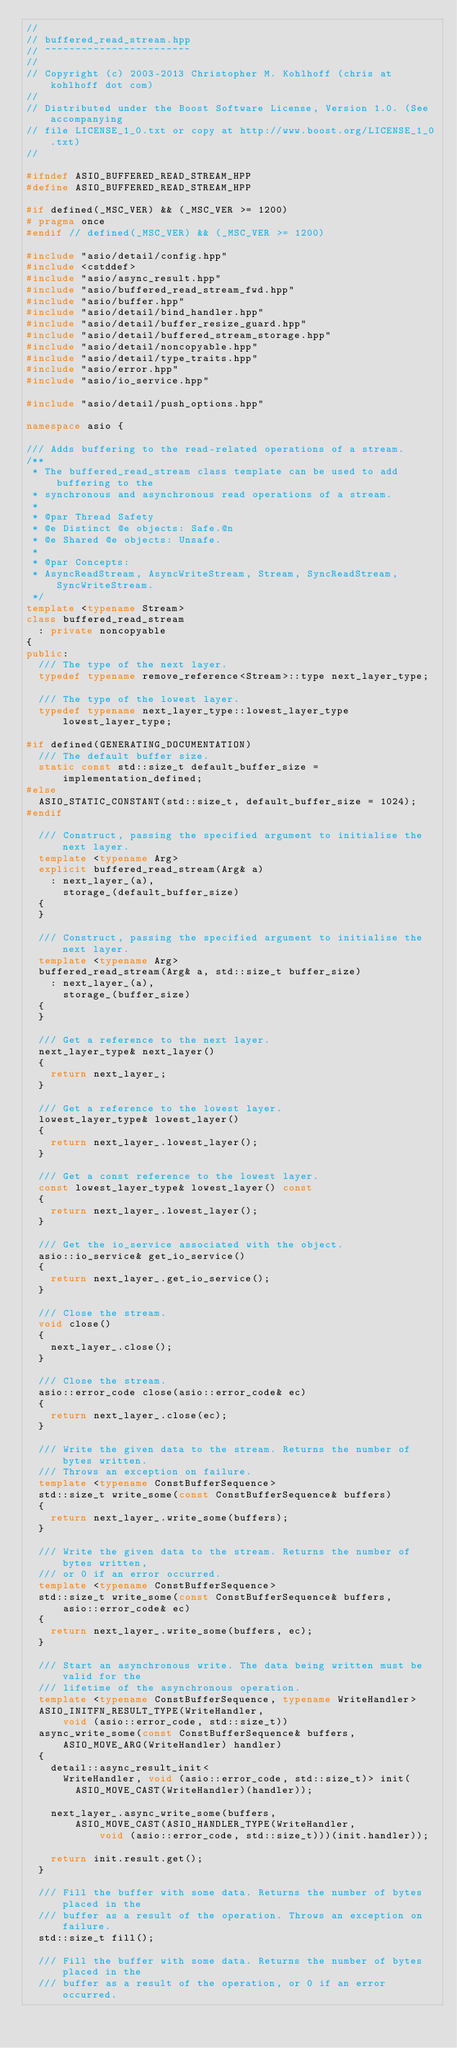<code> <loc_0><loc_0><loc_500><loc_500><_C++_>//
// buffered_read_stream.hpp
// ~~~~~~~~~~~~~~~~~~~~~~~~
//
// Copyright (c) 2003-2013 Christopher M. Kohlhoff (chris at kohlhoff dot com)
//
// Distributed under the Boost Software License, Version 1.0. (See accompanying
// file LICENSE_1_0.txt or copy at http://www.boost.org/LICENSE_1_0.txt)
//

#ifndef ASIO_BUFFERED_READ_STREAM_HPP
#define ASIO_BUFFERED_READ_STREAM_HPP

#if defined(_MSC_VER) && (_MSC_VER >= 1200)
# pragma once
#endif // defined(_MSC_VER) && (_MSC_VER >= 1200)

#include "asio/detail/config.hpp"
#include <cstddef>
#include "asio/async_result.hpp"
#include "asio/buffered_read_stream_fwd.hpp"
#include "asio/buffer.hpp"
#include "asio/detail/bind_handler.hpp"
#include "asio/detail/buffer_resize_guard.hpp"
#include "asio/detail/buffered_stream_storage.hpp"
#include "asio/detail/noncopyable.hpp"
#include "asio/detail/type_traits.hpp"
#include "asio/error.hpp"
#include "asio/io_service.hpp"

#include "asio/detail/push_options.hpp"

namespace asio {

/// Adds buffering to the read-related operations of a stream.
/**
 * The buffered_read_stream class template can be used to add buffering to the
 * synchronous and asynchronous read operations of a stream.
 *
 * @par Thread Safety
 * @e Distinct @e objects: Safe.@n
 * @e Shared @e objects: Unsafe.
 *
 * @par Concepts:
 * AsyncReadStream, AsyncWriteStream, Stream, SyncReadStream, SyncWriteStream.
 */
template <typename Stream>
class buffered_read_stream
  : private noncopyable
{
public:
  /// The type of the next layer.
  typedef typename remove_reference<Stream>::type next_layer_type;

  /// The type of the lowest layer.
  typedef typename next_layer_type::lowest_layer_type lowest_layer_type;

#if defined(GENERATING_DOCUMENTATION)
  /// The default buffer size.
  static const std::size_t default_buffer_size = implementation_defined;
#else
  ASIO_STATIC_CONSTANT(std::size_t, default_buffer_size = 1024);
#endif

  /// Construct, passing the specified argument to initialise the next layer.
  template <typename Arg>
  explicit buffered_read_stream(Arg& a)
    : next_layer_(a),
      storage_(default_buffer_size)
  {
  }

  /// Construct, passing the specified argument to initialise the next layer.
  template <typename Arg>
  buffered_read_stream(Arg& a, std::size_t buffer_size)
    : next_layer_(a),
      storage_(buffer_size)
  {
  }

  /// Get a reference to the next layer.
  next_layer_type& next_layer()
  {
    return next_layer_;
  }

  /// Get a reference to the lowest layer.
  lowest_layer_type& lowest_layer()
  {
    return next_layer_.lowest_layer();
  }

  /// Get a const reference to the lowest layer.
  const lowest_layer_type& lowest_layer() const
  {
    return next_layer_.lowest_layer();
  }

  /// Get the io_service associated with the object.
  asio::io_service& get_io_service()
  {
    return next_layer_.get_io_service();
  }

  /// Close the stream.
  void close()
  {
    next_layer_.close();
  }

  /// Close the stream.
  asio::error_code close(asio::error_code& ec)
  {
    return next_layer_.close(ec);
  }

  /// Write the given data to the stream. Returns the number of bytes written.
  /// Throws an exception on failure.
  template <typename ConstBufferSequence>
  std::size_t write_some(const ConstBufferSequence& buffers)
  {
    return next_layer_.write_some(buffers);
  }

  /// Write the given data to the stream. Returns the number of bytes written,
  /// or 0 if an error occurred.
  template <typename ConstBufferSequence>
  std::size_t write_some(const ConstBufferSequence& buffers,
      asio::error_code& ec)
  {
    return next_layer_.write_some(buffers, ec);
  }

  /// Start an asynchronous write. The data being written must be valid for the
  /// lifetime of the asynchronous operation.
  template <typename ConstBufferSequence, typename WriteHandler>
  ASIO_INITFN_RESULT_TYPE(WriteHandler,
      void (asio::error_code, std::size_t))
  async_write_some(const ConstBufferSequence& buffers,
      ASIO_MOVE_ARG(WriteHandler) handler)
  {
    detail::async_result_init<
      WriteHandler, void (asio::error_code, std::size_t)> init(
        ASIO_MOVE_CAST(WriteHandler)(handler));

    next_layer_.async_write_some(buffers,
        ASIO_MOVE_CAST(ASIO_HANDLER_TYPE(WriteHandler,
            void (asio::error_code, std::size_t)))(init.handler));

    return init.result.get();
  }

  /// Fill the buffer with some data. Returns the number of bytes placed in the
  /// buffer as a result of the operation. Throws an exception on failure.
  std::size_t fill();

  /// Fill the buffer with some data. Returns the number of bytes placed in the
  /// buffer as a result of the operation, or 0 if an error occurred.</code> 